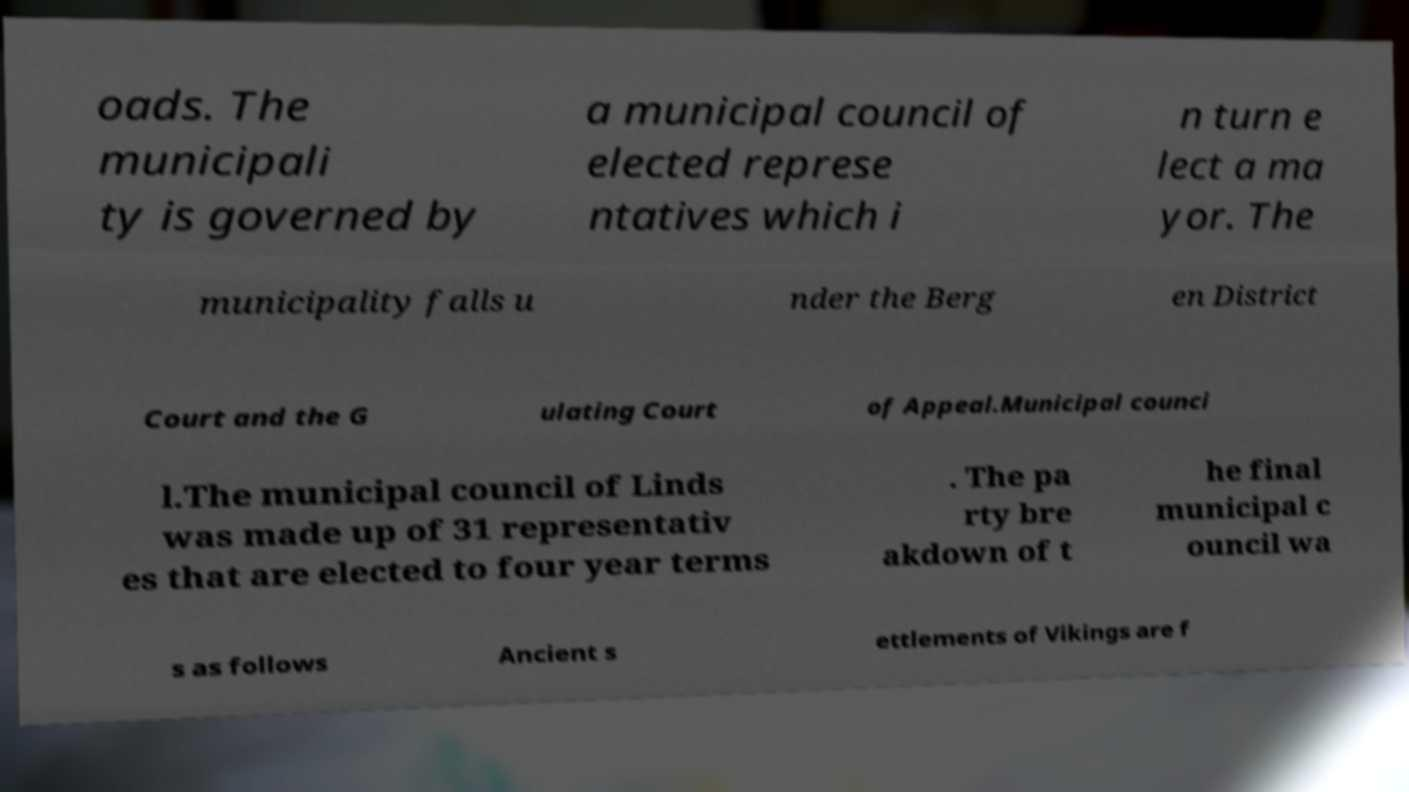Could you extract and type out the text from this image? oads. The municipali ty is governed by a municipal council of elected represe ntatives which i n turn e lect a ma yor. The municipality falls u nder the Berg en District Court and the G ulating Court of Appeal.Municipal counci l.The municipal council of Linds was made up of 31 representativ es that are elected to four year terms . The pa rty bre akdown of t he final municipal c ouncil wa s as follows Ancient s ettlements of Vikings are f 